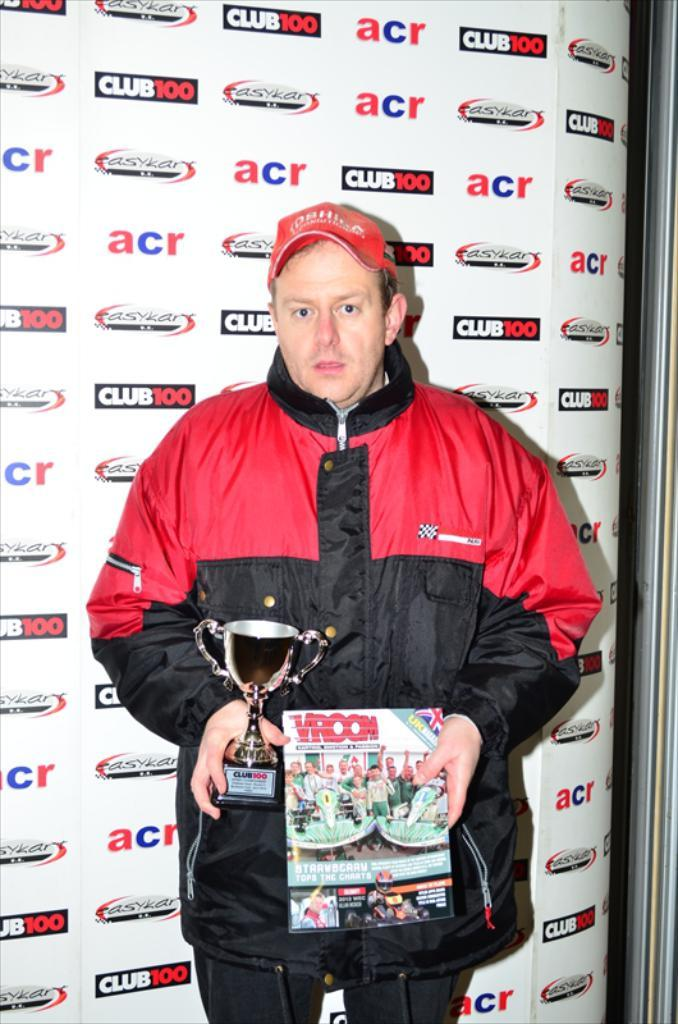What is the person in the image doing? The person is standing in the image and holding a trophy and a book. What might the trophy signify? The trophy might signify an achievement or victory. What else is the person holding in the image? The person is also holding a book. What can be seen at the top of the image? There is a banner with text at the top of the image. What type of whistle can be heard in the image? There is no whistle present in the image, and therefore no sound can be heard. 